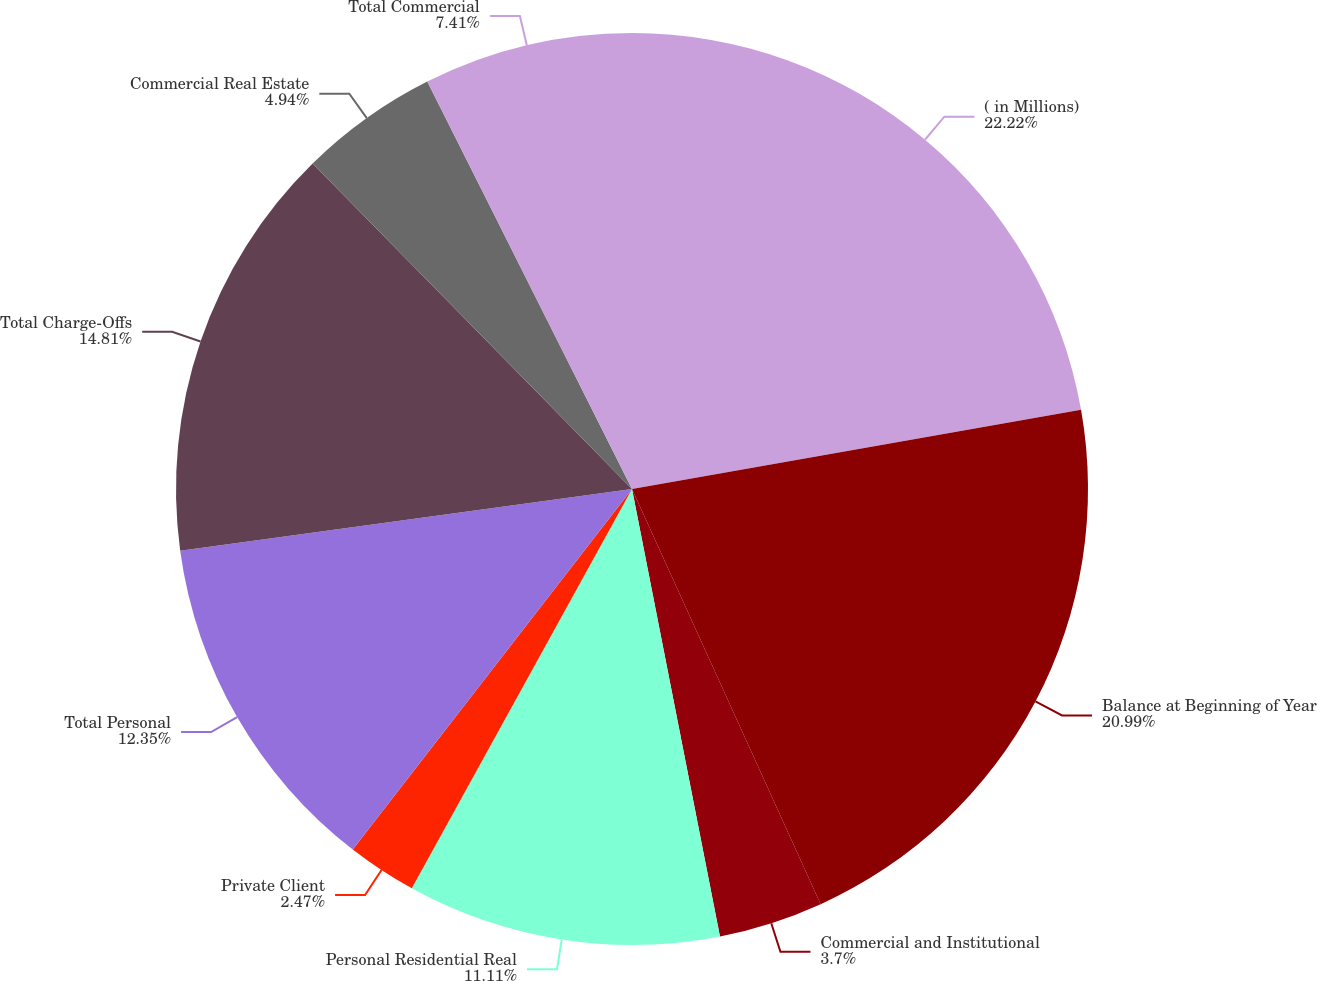Convert chart. <chart><loc_0><loc_0><loc_500><loc_500><pie_chart><fcel>( in Millions)<fcel>Balance at Beginning of Year<fcel>Commercial and Institutional<fcel>Personal Residential Real<fcel>Private Client<fcel>Total Personal<fcel>Total Charge-Offs<fcel>Commercial Real Estate<fcel>Total Commercial<nl><fcel>22.22%<fcel>20.99%<fcel>3.7%<fcel>11.11%<fcel>2.47%<fcel>12.35%<fcel>14.81%<fcel>4.94%<fcel>7.41%<nl></chart> 